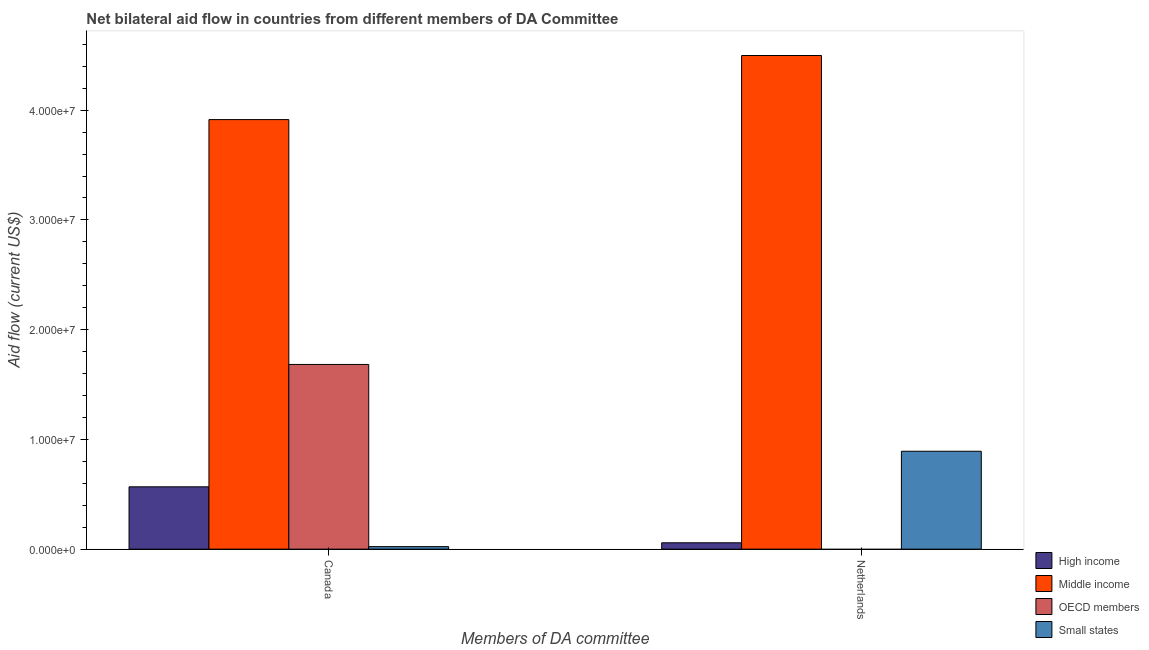How many different coloured bars are there?
Keep it short and to the point. 4. Are the number of bars on each tick of the X-axis equal?
Keep it short and to the point. No. How many bars are there on the 1st tick from the left?
Make the answer very short. 4. What is the label of the 2nd group of bars from the left?
Ensure brevity in your answer.  Netherlands. What is the amount of aid given by canada in Small states?
Provide a short and direct response. 2.30e+05. Across all countries, what is the maximum amount of aid given by canada?
Keep it short and to the point. 3.91e+07. Across all countries, what is the minimum amount of aid given by netherlands?
Offer a very short reply. 0. What is the total amount of aid given by netherlands in the graph?
Ensure brevity in your answer.  5.45e+07. What is the difference between the amount of aid given by canada in Small states and that in Middle income?
Make the answer very short. -3.89e+07. What is the difference between the amount of aid given by netherlands in OECD members and the amount of aid given by canada in Middle income?
Offer a very short reply. -3.91e+07. What is the average amount of aid given by netherlands per country?
Give a very brief answer. 1.36e+07. What is the difference between the amount of aid given by netherlands and amount of aid given by canada in High income?
Ensure brevity in your answer.  -5.10e+06. In how many countries, is the amount of aid given by canada greater than 30000000 US$?
Your answer should be very brief. 1. What is the ratio of the amount of aid given by netherlands in Middle income to that in High income?
Ensure brevity in your answer.  77.55. How many countries are there in the graph?
Keep it short and to the point. 4. Does the graph contain any zero values?
Provide a succinct answer. Yes. Does the graph contain grids?
Offer a very short reply. No. Where does the legend appear in the graph?
Offer a terse response. Bottom right. What is the title of the graph?
Give a very brief answer. Net bilateral aid flow in countries from different members of DA Committee. Does "American Samoa" appear as one of the legend labels in the graph?
Ensure brevity in your answer.  No. What is the label or title of the X-axis?
Provide a short and direct response. Members of DA committee. What is the Aid flow (current US$) of High income in Canada?
Provide a succinct answer. 5.68e+06. What is the Aid flow (current US$) in Middle income in Canada?
Provide a succinct answer. 3.91e+07. What is the Aid flow (current US$) in OECD members in Canada?
Your answer should be very brief. 1.68e+07. What is the Aid flow (current US$) of Small states in Canada?
Provide a short and direct response. 2.30e+05. What is the Aid flow (current US$) in High income in Netherlands?
Your response must be concise. 5.80e+05. What is the Aid flow (current US$) of Middle income in Netherlands?
Your answer should be very brief. 4.50e+07. What is the Aid flow (current US$) of OECD members in Netherlands?
Make the answer very short. 0. What is the Aid flow (current US$) of Small states in Netherlands?
Ensure brevity in your answer.  8.92e+06. Across all Members of DA committee, what is the maximum Aid flow (current US$) of High income?
Keep it short and to the point. 5.68e+06. Across all Members of DA committee, what is the maximum Aid flow (current US$) of Middle income?
Your answer should be very brief. 4.50e+07. Across all Members of DA committee, what is the maximum Aid flow (current US$) in OECD members?
Provide a succinct answer. 1.68e+07. Across all Members of DA committee, what is the maximum Aid flow (current US$) of Small states?
Offer a terse response. 8.92e+06. Across all Members of DA committee, what is the minimum Aid flow (current US$) in High income?
Your response must be concise. 5.80e+05. Across all Members of DA committee, what is the minimum Aid flow (current US$) of Middle income?
Your answer should be very brief. 3.91e+07. Across all Members of DA committee, what is the minimum Aid flow (current US$) in OECD members?
Keep it short and to the point. 0. Across all Members of DA committee, what is the minimum Aid flow (current US$) of Small states?
Make the answer very short. 2.30e+05. What is the total Aid flow (current US$) in High income in the graph?
Ensure brevity in your answer.  6.26e+06. What is the total Aid flow (current US$) in Middle income in the graph?
Offer a very short reply. 8.41e+07. What is the total Aid flow (current US$) in OECD members in the graph?
Your response must be concise. 1.68e+07. What is the total Aid flow (current US$) of Small states in the graph?
Make the answer very short. 9.15e+06. What is the difference between the Aid flow (current US$) of High income in Canada and that in Netherlands?
Your response must be concise. 5.10e+06. What is the difference between the Aid flow (current US$) in Middle income in Canada and that in Netherlands?
Keep it short and to the point. -5.84e+06. What is the difference between the Aid flow (current US$) in Small states in Canada and that in Netherlands?
Offer a very short reply. -8.69e+06. What is the difference between the Aid flow (current US$) of High income in Canada and the Aid flow (current US$) of Middle income in Netherlands?
Provide a succinct answer. -3.93e+07. What is the difference between the Aid flow (current US$) of High income in Canada and the Aid flow (current US$) of Small states in Netherlands?
Make the answer very short. -3.24e+06. What is the difference between the Aid flow (current US$) in Middle income in Canada and the Aid flow (current US$) in Small states in Netherlands?
Your answer should be very brief. 3.02e+07. What is the difference between the Aid flow (current US$) of OECD members in Canada and the Aid flow (current US$) of Small states in Netherlands?
Your answer should be very brief. 7.91e+06. What is the average Aid flow (current US$) of High income per Members of DA committee?
Your answer should be very brief. 3.13e+06. What is the average Aid flow (current US$) in Middle income per Members of DA committee?
Offer a very short reply. 4.21e+07. What is the average Aid flow (current US$) in OECD members per Members of DA committee?
Ensure brevity in your answer.  8.42e+06. What is the average Aid flow (current US$) of Small states per Members of DA committee?
Your response must be concise. 4.58e+06. What is the difference between the Aid flow (current US$) of High income and Aid flow (current US$) of Middle income in Canada?
Ensure brevity in your answer.  -3.35e+07. What is the difference between the Aid flow (current US$) of High income and Aid flow (current US$) of OECD members in Canada?
Ensure brevity in your answer.  -1.12e+07. What is the difference between the Aid flow (current US$) in High income and Aid flow (current US$) in Small states in Canada?
Offer a terse response. 5.45e+06. What is the difference between the Aid flow (current US$) in Middle income and Aid flow (current US$) in OECD members in Canada?
Offer a terse response. 2.23e+07. What is the difference between the Aid flow (current US$) in Middle income and Aid flow (current US$) in Small states in Canada?
Offer a very short reply. 3.89e+07. What is the difference between the Aid flow (current US$) of OECD members and Aid flow (current US$) of Small states in Canada?
Make the answer very short. 1.66e+07. What is the difference between the Aid flow (current US$) of High income and Aid flow (current US$) of Middle income in Netherlands?
Make the answer very short. -4.44e+07. What is the difference between the Aid flow (current US$) in High income and Aid flow (current US$) in Small states in Netherlands?
Provide a succinct answer. -8.34e+06. What is the difference between the Aid flow (current US$) in Middle income and Aid flow (current US$) in Small states in Netherlands?
Offer a very short reply. 3.61e+07. What is the ratio of the Aid flow (current US$) of High income in Canada to that in Netherlands?
Make the answer very short. 9.79. What is the ratio of the Aid flow (current US$) in Middle income in Canada to that in Netherlands?
Offer a terse response. 0.87. What is the ratio of the Aid flow (current US$) of Small states in Canada to that in Netherlands?
Ensure brevity in your answer.  0.03. What is the difference between the highest and the second highest Aid flow (current US$) of High income?
Provide a short and direct response. 5.10e+06. What is the difference between the highest and the second highest Aid flow (current US$) in Middle income?
Make the answer very short. 5.84e+06. What is the difference between the highest and the second highest Aid flow (current US$) in Small states?
Offer a very short reply. 8.69e+06. What is the difference between the highest and the lowest Aid flow (current US$) in High income?
Provide a short and direct response. 5.10e+06. What is the difference between the highest and the lowest Aid flow (current US$) of Middle income?
Your answer should be compact. 5.84e+06. What is the difference between the highest and the lowest Aid flow (current US$) of OECD members?
Provide a short and direct response. 1.68e+07. What is the difference between the highest and the lowest Aid flow (current US$) in Small states?
Make the answer very short. 8.69e+06. 